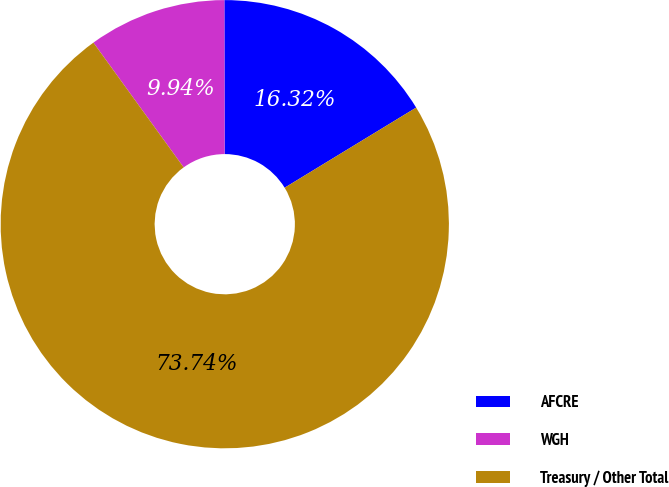<chart> <loc_0><loc_0><loc_500><loc_500><pie_chart><fcel>AFCRE<fcel>WGH<fcel>Treasury / Other Total<nl><fcel>16.32%<fcel>9.94%<fcel>73.74%<nl></chart> 